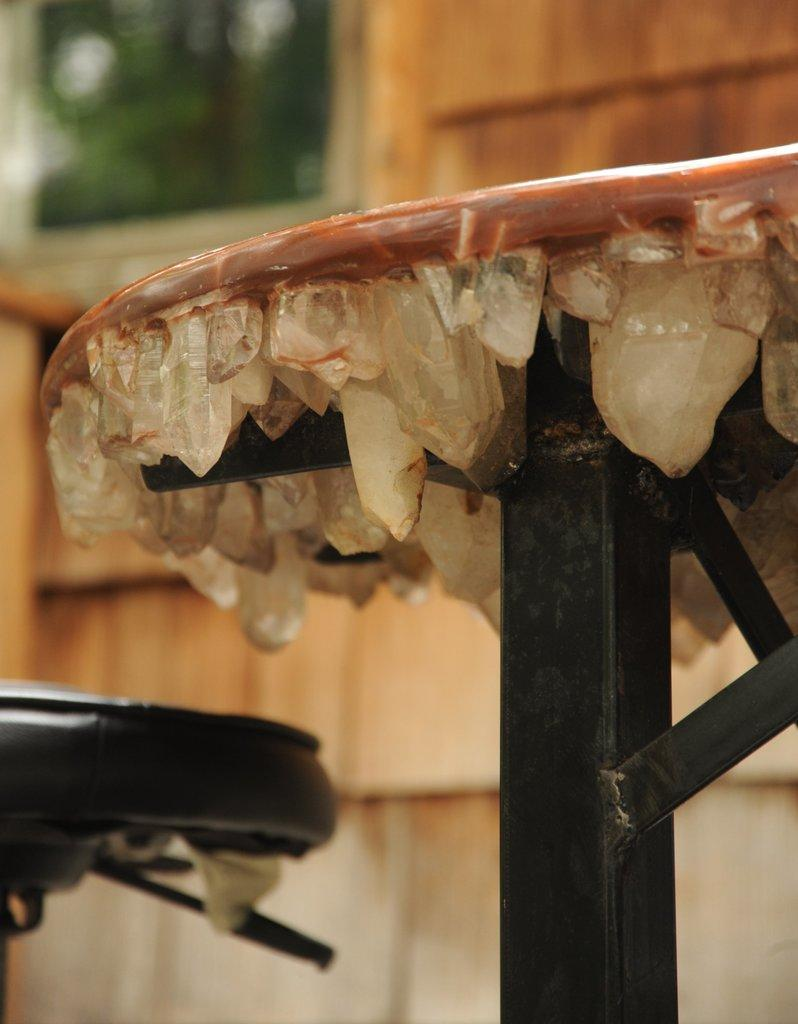What is located in the center of the image? There is a stand and another object in the center of the image. Can you describe the other object in the center of the image? Unfortunately, the facts provided do not give a description of the other object in the center of the image. What can be seen in the background of the image? There is a wall and a window in the background of the image. What is the position of the wall in the image? The facts provided do not give a specific position of the wall in the image. How is the wall being measured in the image? There is no indication in the image that the wall is being measured. 